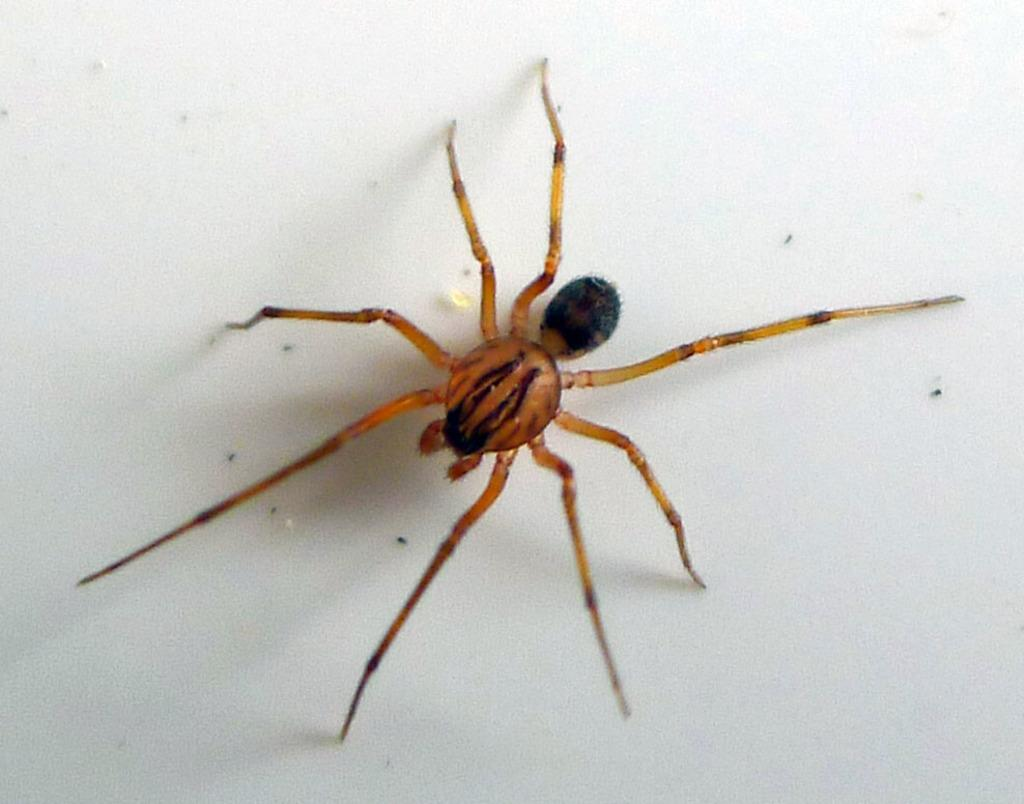What is present in the image? There is a spider in the image. Where is the spider located? The spider is on a wall. What type of wound can be seen on the spider in the image? There is no wound visible on the spider in the image, as it is a photograph and not a living creature. 